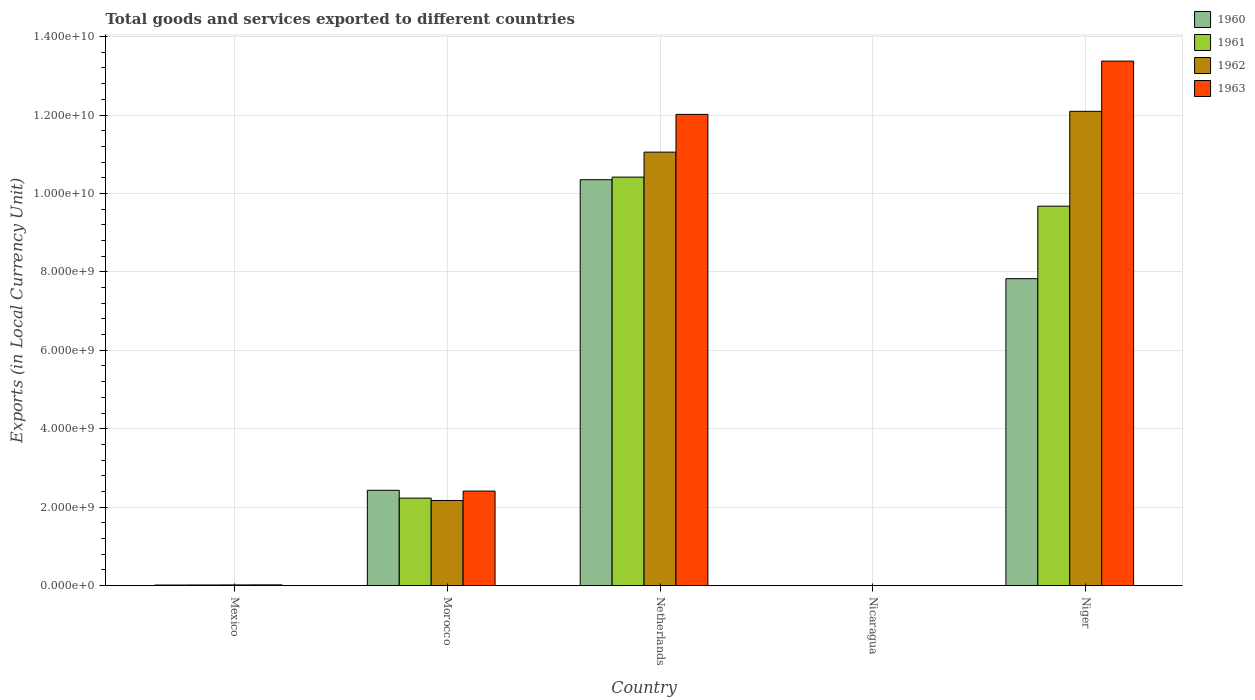How many different coloured bars are there?
Your answer should be very brief. 4. Are the number of bars per tick equal to the number of legend labels?
Provide a succinct answer. Yes. Are the number of bars on each tick of the X-axis equal?
Offer a terse response. Yes. How many bars are there on the 2nd tick from the left?
Provide a short and direct response. 4. How many bars are there on the 5th tick from the right?
Offer a very short reply. 4. What is the label of the 5th group of bars from the left?
Your answer should be compact. Niger. What is the Amount of goods and services exports in 1962 in Nicaragua?
Provide a succinct answer. 0.15. Across all countries, what is the maximum Amount of goods and services exports in 1960?
Make the answer very short. 1.04e+1. Across all countries, what is the minimum Amount of goods and services exports in 1962?
Keep it short and to the point. 0.15. In which country was the Amount of goods and services exports in 1963 maximum?
Keep it short and to the point. Niger. In which country was the Amount of goods and services exports in 1960 minimum?
Your answer should be compact. Nicaragua. What is the total Amount of goods and services exports in 1962 in the graph?
Keep it short and to the point. 2.53e+1. What is the difference between the Amount of goods and services exports in 1960 in Morocco and that in Niger?
Give a very brief answer. -5.40e+09. What is the difference between the Amount of goods and services exports in 1963 in Mexico and the Amount of goods and services exports in 1962 in Nicaragua?
Keep it short and to the point. 1.76e+07. What is the average Amount of goods and services exports in 1962 per country?
Offer a terse response. 5.07e+09. What is the difference between the Amount of goods and services exports of/in 1962 and Amount of goods and services exports of/in 1960 in Niger?
Provide a succinct answer. 4.27e+09. What is the ratio of the Amount of goods and services exports in 1963 in Morocco to that in Netherlands?
Keep it short and to the point. 0.2. Is the Amount of goods and services exports in 1961 in Mexico less than that in Nicaragua?
Keep it short and to the point. No. What is the difference between the highest and the second highest Amount of goods and services exports in 1961?
Offer a terse response. 8.19e+09. What is the difference between the highest and the lowest Amount of goods and services exports in 1962?
Your answer should be compact. 1.21e+1. In how many countries, is the Amount of goods and services exports in 1962 greater than the average Amount of goods and services exports in 1962 taken over all countries?
Offer a terse response. 2. Is it the case that in every country, the sum of the Amount of goods and services exports in 1961 and Amount of goods and services exports in 1960 is greater than the sum of Amount of goods and services exports in 1963 and Amount of goods and services exports in 1962?
Ensure brevity in your answer.  No. What does the 3rd bar from the left in Mexico represents?
Your response must be concise. 1962. What does the 1st bar from the right in Mexico represents?
Your answer should be very brief. 1963. How many bars are there?
Provide a short and direct response. 20. What is the difference between two consecutive major ticks on the Y-axis?
Provide a short and direct response. 2.00e+09. Are the values on the major ticks of Y-axis written in scientific E-notation?
Keep it short and to the point. Yes. Does the graph contain any zero values?
Offer a very short reply. No. What is the title of the graph?
Your answer should be very brief. Total goods and services exported to different countries. Does "1967" appear as one of the legend labels in the graph?
Ensure brevity in your answer.  No. What is the label or title of the Y-axis?
Ensure brevity in your answer.  Exports (in Local Currency Unit). What is the Exports (in Local Currency Unit) of 1960 in Mexico?
Offer a terse response. 1.39e+07. What is the Exports (in Local Currency Unit) in 1961 in Mexico?
Make the answer very short. 1.49e+07. What is the Exports (in Local Currency Unit) of 1962 in Mexico?
Provide a short and direct response. 1.63e+07. What is the Exports (in Local Currency Unit) of 1963 in Mexico?
Provide a short and direct response. 1.76e+07. What is the Exports (in Local Currency Unit) in 1960 in Morocco?
Provide a succinct answer. 2.43e+09. What is the Exports (in Local Currency Unit) of 1961 in Morocco?
Provide a short and direct response. 2.23e+09. What is the Exports (in Local Currency Unit) in 1962 in Morocco?
Your answer should be very brief. 2.17e+09. What is the Exports (in Local Currency Unit) in 1963 in Morocco?
Keep it short and to the point. 2.41e+09. What is the Exports (in Local Currency Unit) in 1960 in Netherlands?
Offer a very short reply. 1.04e+1. What is the Exports (in Local Currency Unit) of 1961 in Netherlands?
Provide a short and direct response. 1.04e+1. What is the Exports (in Local Currency Unit) of 1962 in Netherlands?
Your answer should be compact. 1.11e+1. What is the Exports (in Local Currency Unit) in 1963 in Netherlands?
Offer a very short reply. 1.20e+1. What is the Exports (in Local Currency Unit) of 1960 in Nicaragua?
Provide a short and direct response. 0.11. What is the Exports (in Local Currency Unit) in 1961 in Nicaragua?
Offer a terse response. 0.12. What is the Exports (in Local Currency Unit) in 1962 in Nicaragua?
Offer a terse response. 0.15. What is the Exports (in Local Currency Unit) of 1963 in Nicaragua?
Your response must be concise. 0.18. What is the Exports (in Local Currency Unit) in 1960 in Niger?
Provide a short and direct response. 7.83e+09. What is the Exports (in Local Currency Unit) in 1961 in Niger?
Your answer should be compact. 9.68e+09. What is the Exports (in Local Currency Unit) in 1962 in Niger?
Provide a short and direct response. 1.21e+1. What is the Exports (in Local Currency Unit) of 1963 in Niger?
Provide a succinct answer. 1.34e+1. Across all countries, what is the maximum Exports (in Local Currency Unit) of 1960?
Give a very brief answer. 1.04e+1. Across all countries, what is the maximum Exports (in Local Currency Unit) in 1961?
Your answer should be compact. 1.04e+1. Across all countries, what is the maximum Exports (in Local Currency Unit) of 1962?
Offer a very short reply. 1.21e+1. Across all countries, what is the maximum Exports (in Local Currency Unit) of 1963?
Your answer should be compact. 1.34e+1. Across all countries, what is the minimum Exports (in Local Currency Unit) of 1960?
Your answer should be very brief. 0.11. Across all countries, what is the minimum Exports (in Local Currency Unit) in 1961?
Offer a terse response. 0.12. Across all countries, what is the minimum Exports (in Local Currency Unit) in 1962?
Offer a terse response. 0.15. Across all countries, what is the minimum Exports (in Local Currency Unit) of 1963?
Provide a short and direct response. 0.18. What is the total Exports (in Local Currency Unit) in 1960 in the graph?
Keep it short and to the point. 2.06e+1. What is the total Exports (in Local Currency Unit) of 1961 in the graph?
Ensure brevity in your answer.  2.23e+1. What is the total Exports (in Local Currency Unit) in 1962 in the graph?
Make the answer very short. 2.53e+1. What is the total Exports (in Local Currency Unit) in 1963 in the graph?
Your answer should be compact. 2.78e+1. What is the difference between the Exports (in Local Currency Unit) in 1960 in Mexico and that in Morocco?
Your answer should be compact. -2.42e+09. What is the difference between the Exports (in Local Currency Unit) in 1961 in Mexico and that in Morocco?
Your response must be concise. -2.22e+09. What is the difference between the Exports (in Local Currency Unit) of 1962 in Mexico and that in Morocco?
Make the answer very short. -2.15e+09. What is the difference between the Exports (in Local Currency Unit) of 1963 in Mexico and that in Morocco?
Make the answer very short. -2.39e+09. What is the difference between the Exports (in Local Currency Unit) of 1960 in Mexico and that in Netherlands?
Offer a very short reply. -1.03e+1. What is the difference between the Exports (in Local Currency Unit) in 1961 in Mexico and that in Netherlands?
Provide a short and direct response. -1.04e+1. What is the difference between the Exports (in Local Currency Unit) in 1962 in Mexico and that in Netherlands?
Your response must be concise. -1.10e+1. What is the difference between the Exports (in Local Currency Unit) in 1963 in Mexico and that in Netherlands?
Offer a terse response. -1.20e+1. What is the difference between the Exports (in Local Currency Unit) in 1960 in Mexico and that in Nicaragua?
Your answer should be compact. 1.39e+07. What is the difference between the Exports (in Local Currency Unit) in 1961 in Mexico and that in Nicaragua?
Ensure brevity in your answer.  1.49e+07. What is the difference between the Exports (in Local Currency Unit) of 1962 in Mexico and that in Nicaragua?
Ensure brevity in your answer.  1.63e+07. What is the difference between the Exports (in Local Currency Unit) in 1963 in Mexico and that in Nicaragua?
Offer a terse response. 1.76e+07. What is the difference between the Exports (in Local Currency Unit) of 1960 in Mexico and that in Niger?
Your answer should be compact. -7.81e+09. What is the difference between the Exports (in Local Currency Unit) of 1961 in Mexico and that in Niger?
Give a very brief answer. -9.66e+09. What is the difference between the Exports (in Local Currency Unit) of 1962 in Mexico and that in Niger?
Your answer should be very brief. -1.21e+1. What is the difference between the Exports (in Local Currency Unit) of 1963 in Mexico and that in Niger?
Ensure brevity in your answer.  -1.34e+1. What is the difference between the Exports (in Local Currency Unit) of 1960 in Morocco and that in Netherlands?
Provide a succinct answer. -7.92e+09. What is the difference between the Exports (in Local Currency Unit) of 1961 in Morocco and that in Netherlands?
Offer a very short reply. -8.19e+09. What is the difference between the Exports (in Local Currency Unit) of 1962 in Morocco and that in Netherlands?
Your response must be concise. -8.88e+09. What is the difference between the Exports (in Local Currency Unit) of 1963 in Morocco and that in Netherlands?
Give a very brief answer. -9.61e+09. What is the difference between the Exports (in Local Currency Unit) in 1960 in Morocco and that in Nicaragua?
Your answer should be very brief. 2.43e+09. What is the difference between the Exports (in Local Currency Unit) in 1961 in Morocco and that in Nicaragua?
Your response must be concise. 2.23e+09. What is the difference between the Exports (in Local Currency Unit) of 1962 in Morocco and that in Nicaragua?
Your answer should be compact. 2.17e+09. What is the difference between the Exports (in Local Currency Unit) of 1963 in Morocco and that in Nicaragua?
Your response must be concise. 2.41e+09. What is the difference between the Exports (in Local Currency Unit) in 1960 in Morocco and that in Niger?
Provide a succinct answer. -5.40e+09. What is the difference between the Exports (in Local Currency Unit) in 1961 in Morocco and that in Niger?
Your answer should be very brief. -7.45e+09. What is the difference between the Exports (in Local Currency Unit) of 1962 in Morocco and that in Niger?
Your answer should be very brief. -9.92e+09. What is the difference between the Exports (in Local Currency Unit) of 1963 in Morocco and that in Niger?
Ensure brevity in your answer.  -1.10e+1. What is the difference between the Exports (in Local Currency Unit) of 1960 in Netherlands and that in Nicaragua?
Ensure brevity in your answer.  1.04e+1. What is the difference between the Exports (in Local Currency Unit) in 1961 in Netherlands and that in Nicaragua?
Provide a short and direct response. 1.04e+1. What is the difference between the Exports (in Local Currency Unit) of 1962 in Netherlands and that in Nicaragua?
Provide a short and direct response. 1.11e+1. What is the difference between the Exports (in Local Currency Unit) of 1963 in Netherlands and that in Nicaragua?
Provide a succinct answer. 1.20e+1. What is the difference between the Exports (in Local Currency Unit) in 1960 in Netherlands and that in Niger?
Your answer should be very brief. 2.52e+09. What is the difference between the Exports (in Local Currency Unit) of 1961 in Netherlands and that in Niger?
Your answer should be very brief. 7.41e+08. What is the difference between the Exports (in Local Currency Unit) in 1962 in Netherlands and that in Niger?
Offer a terse response. -1.04e+09. What is the difference between the Exports (in Local Currency Unit) in 1963 in Netherlands and that in Niger?
Your response must be concise. -1.36e+09. What is the difference between the Exports (in Local Currency Unit) in 1960 in Nicaragua and that in Niger?
Give a very brief answer. -7.83e+09. What is the difference between the Exports (in Local Currency Unit) of 1961 in Nicaragua and that in Niger?
Your response must be concise. -9.68e+09. What is the difference between the Exports (in Local Currency Unit) of 1962 in Nicaragua and that in Niger?
Make the answer very short. -1.21e+1. What is the difference between the Exports (in Local Currency Unit) in 1963 in Nicaragua and that in Niger?
Your response must be concise. -1.34e+1. What is the difference between the Exports (in Local Currency Unit) in 1960 in Mexico and the Exports (in Local Currency Unit) in 1961 in Morocco?
Your answer should be compact. -2.22e+09. What is the difference between the Exports (in Local Currency Unit) of 1960 in Mexico and the Exports (in Local Currency Unit) of 1962 in Morocco?
Offer a very short reply. -2.16e+09. What is the difference between the Exports (in Local Currency Unit) of 1960 in Mexico and the Exports (in Local Currency Unit) of 1963 in Morocco?
Provide a succinct answer. -2.40e+09. What is the difference between the Exports (in Local Currency Unit) of 1961 in Mexico and the Exports (in Local Currency Unit) of 1962 in Morocco?
Keep it short and to the point. -2.16e+09. What is the difference between the Exports (in Local Currency Unit) in 1961 in Mexico and the Exports (in Local Currency Unit) in 1963 in Morocco?
Give a very brief answer. -2.40e+09. What is the difference between the Exports (in Local Currency Unit) in 1962 in Mexico and the Exports (in Local Currency Unit) in 1963 in Morocco?
Your answer should be very brief. -2.39e+09. What is the difference between the Exports (in Local Currency Unit) of 1960 in Mexico and the Exports (in Local Currency Unit) of 1961 in Netherlands?
Offer a very short reply. -1.04e+1. What is the difference between the Exports (in Local Currency Unit) in 1960 in Mexico and the Exports (in Local Currency Unit) in 1962 in Netherlands?
Your answer should be compact. -1.10e+1. What is the difference between the Exports (in Local Currency Unit) in 1960 in Mexico and the Exports (in Local Currency Unit) in 1963 in Netherlands?
Offer a very short reply. -1.20e+1. What is the difference between the Exports (in Local Currency Unit) in 1961 in Mexico and the Exports (in Local Currency Unit) in 1962 in Netherlands?
Your answer should be very brief. -1.10e+1. What is the difference between the Exports (in Local Currency Unit) in 1961 in Mexico and the Exports (in Local Currency Unit) in 1963 in Netherlands?
Your answer should be very brief. -1.20e+1. What is the difference between the Exports (in Local Currency Unit) in 1962 in Mexico and the Exports (in Local Currency Unit) in 1963 in Netherlands?
Give a very brief answer. -1.20e+1. What is the difference between the Exports (in Local Currency Unit) of 1960 in Mexico and the Exports (in Local Currency Unit) of 1961 in Nicaragua?
Your response must be concise. 1.39e+07. What is the difference between the Exports (in Local Currency Unit) in 1960 in Mexico and the Exports (in Local Currency Unit) in 1962 in Nicaragua?
Provide a short and direct response. 1.39e+07. What is the difference between the Exports (in Local Currency Unit) in 1960 in Mexico and the Exports (in Local Currency Unit) in 1963 in Nicaragua?
Your response must be concise. 1.39e+07. What is the difference between the Exports (in Local Currency Unit) in 1961 in Mexico and the Exports (in Local Currency Unit) in 1962 in Nicaragua?
Your answer should be compact. 1.49e+07. What is the difference between the Exports (in Local Currency Unit) in 1961 in Mexico and the Exports (in Local Currency Unit) in 1963 in Nicaragua?
Offer a terse response. 1.49e+07. What is the difference between the Exports (in Local Currency Unit) in 1962 in Mexico and the Exports (in Local Currency Unit) in 1963 in Nicaragua?
Provide a short and direct response. 1.63e+07. What is the difference between the Exports (in Local Currency Unit) of 1960 in Mexico and the Exports (in Local Currency Unit) of 1961 in Niger?
Your response must be concise. -9.66e+09. What is the difference between the Exports (in Local Currency Unit) in 1960 in Mexico and the Exports (in Local Currency Unit) in 1962 in Niger?
Offer a terse response. -1.21e+1. What is the difference between the Exports (in Local Currency Unit) in 1960 in Mexico and the Exports (in Local Currency Unit) in 1963 in Niger?
Your answer should be very brief. -1.34e+1. What is the difference between the Exports (in Local Currency Unit) in 1961 in Mexico and the Exports (in Local Currency Unit) in 1962 in Niger?
Ensure brevity in your answer.  -1.21e+1. What is the difference between the Exports (in Local Currency Unit) of 1961 in Mexico and the Exports (in Local Currency Unit) of 1963 in Niger?
Offer a terse response. -1.34e+1. What is the difference between the Exports (in Local Currency Unit) of 1962 in Mexico and the Exports (in Local Currency Unit) of 1963 in Niger?
Offer a very short reply. -1.34e+1. What is the difference between the Exports (in Local Currency Unit) in 1960 in Morocco and the Exports (in Local Currency Unit) in 1961 in Netherlands?
Your response must be concise. -7.99e+09. What is the difference between the Exports (in Local Currency Unit) of 1960 in Morocco and the Exports (in Local Currency Unit) of 1962 in Netherlands?
Your answer should be compact. -8.62e+09. What is the difference between the Exports (in Local Currency Unit) of 1960 in Morocco and the Exports (in Local Currency Unit) of 1963 in Netherlands?
Your answer should be compact. -9.59e+09. What is the difference between the Exports (in Local Currency Unit) of 1961 in Morocco and the Exports (in Local Currency Unit) of 1962 in Netherlands?
Ensure brevity in your answer.  -8.82e+09. What is the difference between the Exports (in Local Currency Unit) of 1961 in Morocco and the Exports (in Local Currency Unit) of 1963 in Netherlands?
Your response must be concise. -9.79e+09. What is the difference between the Exports (in Local Currency Unit) of 1962 in Morocco and the Exports (in Local Currency Unit) of 1963 in Netherlands?
Keep it short and to the point. -9.85e+09. What is the difference between the Exports (in Local Currency Unit) of 1960 in Morocco and the Exports (in Local Currency Unit) of 1961 in Nicaragua?
Your answer should be compact. 2.43e+09. What is the difference between the Exports (in Local Currency Unit) of 1960 in Morocco and the Exports (in Local Currency Unit) of 1962 in Nicaragua?
Provide a short and direct response. 2.43e+09. What is the difference between the Exports (in Local Currency Unit) in 1960 in Morocco and the Exports (in Local Currency Unit) in 1963 in Nicaragua?
Make the answer very short. 2.43e+09. What is the difference between the Exports (in Local Currency Unit) of 1961 in Morocco and the Exports (in Local Currency Unit) of 1962 in Nicaragua?
Offer a very short reply. 2.23e+09. What is the difference between the Exports (in Local Currency Unit) of 1961 in Morocco and the Exports (in Local Currency Unit) of 1963 in Nicaragua?
Provide a succinct answer. 2.23e+09. What is the difference between the Exports (in Local Currency Unit) of 1962 in Morocco and the Exports (in Local Currency Unit) of 1963 in Nicaragua?
Your response must be concise. 2.17e+09. What is the difference between the Exports (in Local Currency Unit) in 1960 in Morocco and the Exports (in Local Currency Unit) in 1961 in Niger?
Make the answer very short. -7.25e+09. What is the difference between the Exports (in Local Currency Unit) of 1960 in Morocco and the Exports (in Local Currency Unit) of 1962 in Niger?
Provide a short and direct response. -9.66e+09. What is the difference between the Exports (in Local Currency Unit) of 1960 in Morocco and the Exports (in Local Currency Unit) of 1963 in Niger?
Keep it short and to the point. -1.09e+1. What is the difference between the Exports (in Local Currency Unit) in 1961 in Morocco and the Exports (in Local Currency Unit) in 1962 in Niger?
Your response must be concise. -9.86e+09. What is the difference between the Exports (in Local Currency Unit) in 1961 in Morocco and the Exports (in Local Currency Unit) in 1963 in Niger?
Your answer should be compact. -1.11e+1. What is the difference between the Exports (in Local Currency Unit) of 1962 in Morocco and the Exports (in Local Currency Unit) of 1963 in Niger?
Your answer should be compact. -1.12e+1. What is the difference between the Exports (in Local Currency Unit) in 1960 in Netherlands and the Exports (in Local Currency Unit) in 1961 in Nicaragua?
Ensure brevity in your answer.  1.04e+1. What is the difference between the Exports (in Local Currency Unit) of 1960 in Netherlands and the Exports (in Local Currency Unit) of 1962 in Nicaragua?
Your response must be concise. 1.04e+1. What is the difference between the Exports (in Local Currency Unit) of 1960 in Netherlands and the Exports (in Local Currency Unit) of 1963 in Nicaragua?
Keep it short and to the point. 1.04e+1. What is the difference between the Exports (in Local Currency Unit) of 1961 in Netherlands and the Exports (in Local Currency Unit) of 1962 in Nicaragua?
Your response must be concise. 1.04e+1. What is the difference between the Exports (in Local Currency Unit) of 1961 in Netherlands and the Exports (in Local Currency Unit) of 1963 in Nicaragua?
Ensure brevity in your answer.  1.04e+1. What is the difference between the Exports (in Local Currency Unit) of 1962 in Netherlands and the Exports (in Local Currency Unit) of 1963 in Nicaragua?
Offer a very short reply. 1.11e+1. What is the difference between the Exports (in Local Currency Unit) in 1960 in Netherlands and the Exports (in Local Currency Unit) in 1961 in Niger?
Give a very brief answer. 6.75e+08. What is the difference between the Exports (in Local Currency Unit) of 1960 in Netherlands and the Exports (in Local Currency Unit) of 1962 in Niger?
Offer a terse response. -1.74e+09. What is the difference between the Exports (in Local Currency Unit) of 1960 in Netherlands and the Exports (in Local Currency Unit) of 1963 in Niger?
Offer a terse response. -3.02e+09. What is the difference between the Exports (in Local Currency Unit) of 1961 in Netherlands and the Exports (in Local Currency Unit) of 1962 in Niger?
Provide a succinct answer. -1.68e+09. What is the difference between the Exports (in Local Currency Unit) in 1961 in Netherlands and the Exports (in Local Currency Unit) in 1963 in Niger?
Offer a very short reply. -2.96e+09. What is the difference between the Exports (in Local Currency Unit) of 1962 in Netherlands and the Exports (in Local Currency Unit) of 1963 in Niger?
Give a very brief answer. -2.32e+09. What is the difference between the Exports (in Local Currency Unit) in 1960 in Nicaragua and the Exports (in Local Currency Unit) in 1961 in Niger?
Make the answer very short. -9.68e+09. What is the difference between the Exports (in Local Currency Unit) in 1960 in Nicaragua and the Exports (in Local Currency Unit) in 1962 in Niger?
Provide a succinct answer. -1.21e+1. What is the difference between the Exports (in Local Currency Unit) in 1960 in Nicaragua and the Exports (in Local Currency Unit) in 1963 in Niger?
Ensure brevity in your answer.  -1.34e+1. What is the difference between the Exports (in Local Currency Unit) of 1961 in Nicaragua and the Exports (in Local Currency Unit) of 1962 in Niger?
Your answer should be very brief. -1.21e+1. What is the difference between the Exports (in Local Currency Unit) in 1961 in Nicaragua and the Exports (in Local Currency Unit) in 1963 in Niger?
Your answer should be very brief. -1.34e+1. What is the difference between the Exports (in Local Currency Unit) in 1962 in Nicaragua and the Exports (in Local Currency Unit) in 1963 in Niger?
Your answer should be very brief. -1.34e+1. What is the average Exports (in Local Currency Unit) in 1960 per country?
Offer a very short reply. 4.12e+09. What is the average Exports (in Local Currency Unit) of 1961 per country?
Ensure brevity in your answer.  4.47e+09. What is the average Exports (in Local Currency Unit) of 1962 per country?
Make the answer very short. 5.07e+09. What is the average Exports (in Local Currency Unit) of 1963 per country?
Your answer should be very brief. 5.56e+09. What is the difference between the Exports (in Local Currency Unit) in 1960 and Exports (in Local Currency Unit) in 1961 in Mexico?
Your answer should be very brief. -1.03e+06. What is the difference between the Exports (in Local Currency Unit) of 1960 and Exports (in Local Currency Unit) of 1962 in Mexico?
Offer a very short reply. -2.42e+06. What is the difference between the Exports (in Local Currency Unit) in 1960 and Exports (in Local Currency Unit) in 1963 in Mexico?
Your answer should be very brief. -3.77e+06. What is the difference between the Exports (in Local Currency Unit) in 1961 and Exports (in Local Currency Unit) in 1962 in Mexico?
Your answer should be compact. -1.39e+06. What is the difference between the Exports (in Local Currency Unit) in 1961 and Exports (in Local Currency Unit) in 1963 in Mexico?
Provide a succinct answer. -2.75e+06. What is the difference between the Exports (in Local Currency Unit) in 1962 and Exports (in Local Currency Unit) in 1963 in Mexico?
Provide a succinct answer. -1.36e+06. What is the difference between the Exports (in Local Currency Unit) in 1960 and Exports (in Local Currency Unit) in 1962 in Morocco?
Your answer should be compact. 2.60e+08. What is the difference between the Exports (in Local Currency Unit) in 1961 and Exports (in Local Currency Unit) in 1962 in Morocco?
Offer a very short reply. 6.00e+07. What is the difference between the Exports (in Local Currency Unit) in 1961 and Exports (in Local Currency Unit) in 1963 in Morocco?
Provide a succinct answer. -1.80e+08. What is the difference between the Exports (in Local Currency Unit) of 1962 and Exports (in Local Currency Unit) of 1963 in Morocco?
Your answer should be very brief. -2.40e+08. What is the difference between the Exports (in Local Currency Unit) of 1960 and Exports (in Local Currency Unit) of 1961 in Netherlands?
Offer a very short reply. -6.60e+07. What is the difference between the Exports (in Local Currency Unit) of 1960 and Exports (in Local Currency Unit) of 1962 in Netherlands?
Make the answer very short. -7.03e+08. What is the difference between the Exports (in Local Currency Unit) of 1960 and Exports (in Local Currency Unit) of 1963 in Netherlands?
Give a very brief answer. -1.67e+09. What is the difference between the Exports (in Local Currency Unit) of 1961 and Exports (in Local Currency Unit) of 1962 in Netherlands?
Provide a short and direct response. -6.37e+08. What is the difference between the Exports (in Local Currency Unit) in 1961 and Exports (in Local Currency Unit) in 1963 in Netherlands?
Provide a short and direct response. -1.60e+09. What is the difference between the Exports (in Local Currency Unit) of 1962 and Exports (in Local Currency Unit) of 1963 in Netherlands?
Provide a short and direct response. -9.62e+08. What is the difference between the Exports (in Local Currency Unit) in 1960 and Exports (in Local Currency Unit) in 1961 in Nicaragua?
Offer a terse response. -0.01. What is the difference between the Exports (in Local Currency Unit) in 1960 and Exports (in Local Currency Unit) in 1962 in Nicaragua?
Your response must be concise. -0.04. What is the difference between the Exports (in Local Currency Unit) in 1960 and Exports (in Local Currency Unit) in 1963 in Nicaragua?
Your response must be concise. -0.07. What is the difference between the Exports (in Local Currency Unit) of 1961 and Exports (in Local Currency Unit) of 1962 in Nicaragua?
Ensure brevity in your answer.  -0.03. What is the difference between the Exports (in Local Currency Unit) in 1961 and Exports (in Local Currency Unit) in 1963 in Nicaragua?
Give a very brief answer. -0.06. What is the difference between the Exports (in Local Currency Unit) in 1962 and Exports (in Local Currency Unit) in 1963 in Nicaragua?
Ensure brevity in your answer.  -0.03. What is the difference between the Exports (in Local Currency Unit) in 1960 and Exports (in Local Currency Unit) in 1961 in Niger?
Make the answer very short. -1.85e+09. What is the difference between the Exports (in Local Currency Unit) of 1960 and Exports (in Local Currency Unit) of 1962 in Niger?
Offer a very short reply. -4.27e+09. What is the difference between the Exports (in Local Currency Unit) in 1960 and Exports (in Local Currency Unit) in 1963 in Niger?
Keep it short and to the point. -5.55e+09. What is the difference between the Exports (in Local Currency Unit) in 1961 and Exports (in Local Currency Unit) in 1962 in Niger?
Your response must be concise. -2.42e+09. What is the difference between the Exports (in Local Currency Unit) of 1961 and Exports (in Local Currency Unit) of 1963 in Niger?
Provide a short and direct response. -3.70e+09. What is the difference between the Exports (in Local Currency Unit) of 1962 and Exports (in Local Currency Unit) of 1963 in Niger?
Ensure brevity in your answer.  -1.28e+09. What is the ratio of the Exports (in Local Currency Unit) of 1960 in Mexico to that in Morocco?
Your response must be concise. 0.01. What is the ratio of the Exports (in Local Currency Unit) of 1961 in Mexico to that in Morocco?
Make the answer very short. 0.01. What is the ratio of the Exports (in Local Currency Unit) of 1962 in Mexico to that in Morocco?
Give a very brief answer. 0.01. What is the ratio of the Exports (in Local Currency Unit) in 1963 in Mexico to that in Morocco?
Your response must be concise. 0.01. What is the ratio of the Exports (in Local Currency Unit) of 1960 in Mexico to that in Netherlands?
Make the answer very short. 0. What is the ratio of the Exports (in Local Currency Unit) of 1961 in Mexico to that in Netherlands?
Offer a terse response. 0. What is the ratio of the Exports (in Local Currency Unit) of 1962 in Mexico to that in Netherlands?
Your answer should be very brief. 0. What is the ratio of the Exports (in Local Currency Unit) in 1963 in Mexico to that in Netherlands?
Offer a terse response. 0. What is the ratio of the Exports (in Local Currency Unit) in 1960 in Mexico to that in Nicaragua?
Offer a very short reply. 1.25e+08. What is the ratio of the Exports (in Local Currency Unit) of 1961 in Mexico to that in Nicaragua?
Offer a terse response. 1.26e+08. What is the ratio of the Exports (in Local Currency Unit) in 1962 in Mexico to that in Nicaragua?
Your answer should be compact. 1.11e+08. What is the ratio of the Exports (in Local Currency Unit) of 1963 in Mexico to that in Nicaragua?
Give a very brief answer. 9.95e+07. What is the ratio of the Exports (in Local Currency Unit) of 1960 in Mexico to that in Niger?
Make the answer very short. 0. What is the ratio of the Exports (in Local Currency Unit) in 1961 in Mexico to that in Niger?
Offer a very short reply. 0. What is the ratio of the Exports (in Local Currency Unit) of 1962 in Mexico to that in Niger?
Your response must be concise. 0. What is the ratio of the Exports (in Local Currency Unit) in 1963 in Mexico to that in Niger?
Your response must be concise. 0. What is the ratio of the Exports (in Local Currency Unit) in 1960 in Morocco to that in Netherlands?
Keep it short and to the point. 0.23. What is the ratio of the Exports (in Local Currency Unit) of 1961 in Morocco to that in Netherlands?
Provide a succinct answer. 0.21. What is the ratio of the Exports (in Local Currency Unit) of 1962 in Morocco to that in Netherlands?
Provide a short and direct response. 0.2. What is the ratio of the Exports (in Local Currency Unit) in 1963 in Morocco to that in Netherlands?
Ensure brevity in your answer.  0.2. What is the ratio of the Exports (in Local Currency Unit) in 1960 in Morocco to that in Nicaragua?
Provide a succinct answer. 2.19e+1. What is the ratio of the Exports (in Local Currency Unit) in 1961 in Morocco to that in Nicaragua?
Give a very brief answer. 1.89e+1. What is the ratio of the Exports (in Local Currency Unit) in 1962 in Morocco to that in Nicaragua?
Give a very brief answer. 1.47e+1. What is the ratio of the Exports (in Local Currency Unit) of 1963 in Morocco to that in Nicaragua?
Offer a terse response. 1.36e+1. What is the ratio of the Exports (in Local Currency Unit) of 1960 in Morocco to that in Niger?
Ensure brevity in your answer.  0.31. What is the ratio of the Exports (in Local Currency Unit) in 1961 in Morocco to that in Niger?
Offer a terse response. 0.23. What is the ratio of the Exports (in Local Currency Unit) in 1962 in Morocco to that in Niger?
Your answer should be very brief. 0.18. What is the ratio of the Exports (in Local Currency Unit) in 1963 in Morocco to that in Niger?
Your answer should be very brief. 0.18. What is the ratio of the Exports (in Local Currency Unit) of 1960 in Netherlands to that in Nicaragua?
Keep it short and to the point. 9.31e+1. What is the ratio of the Exports (in Local Currency Unit) of 1961 in Netherlands to that in Nicaragua?
Make the answer very short. 8.81e+1. What is the ratio of the Exports (in Local Currency Unit) of 1962 in Netherlands to that in Nicaragua?
Your response must be concise. 7.51e+1. What is the ratio of the Exports (in Local Currency Unit) of 1963 in Netherlands to that in Nicaragua?
Make the answer very short. 6.78e+1. What is the ratio of the Exports (in Local Currency Unit) of 1960 in Netherlands to that in Niger?
Provide a short and direct response. 1.32. What is the ratio of the Exports (in Local Currency Unit) in 1961 in Netherlands to that in Niger?
Give a very brief answer. 1.08. What is the ratio of the Exports (in Local Currency Unit) of 1962 in Netherlands to that in Niger?
Your answer should be very brief. 0.91. What is the ratio of the Exports (in Local Currency Unit) in 1963 in Netherlands to that in Niger?
Give a very brief answer. 0.9. What is the ratio of the Exports (in Local Currency Unit) of 1963 in Nicaragua to that in Niger?
Give a very brief answer. 0. What is the difference between the highest and the second highest Exports (in Local Currency Unit) of 1960?
Make the answer very short. 2.52e+09. What is the difference between the highest and the second highest Exports (in Local Currency Unit) in 1961?
Offer a terse response. 7.41e+08. What is the difference between the highest and the second highest Exports (in Local Currency Unit) of 1962?
Provide a short and direct response. 1.04e+09. What is the difference between the highest and the second highest Exports (in Local Currency Unit) in 1963?
Make the answer very short. 1.36e+09. What is the difference between the highest and the lowest Exports (in Local Currency Unit) of 1960?
Your answer should be very brief. 1.04e+1. What is the difference between the highest and the lowest Exports (in Local Currency Unit) of 1961?
Provide a short and direct response. 1.04e+1. What is the difference between the highest and the lowest Exports (in Local Currency Unit) of 1962?
Provide a succinct answer. 1.21e+1. What is the difference between the highest and the lowest Exports (in Local Currency Unit) of 1963?
Keep it short and to the point. 1.34e+1. 